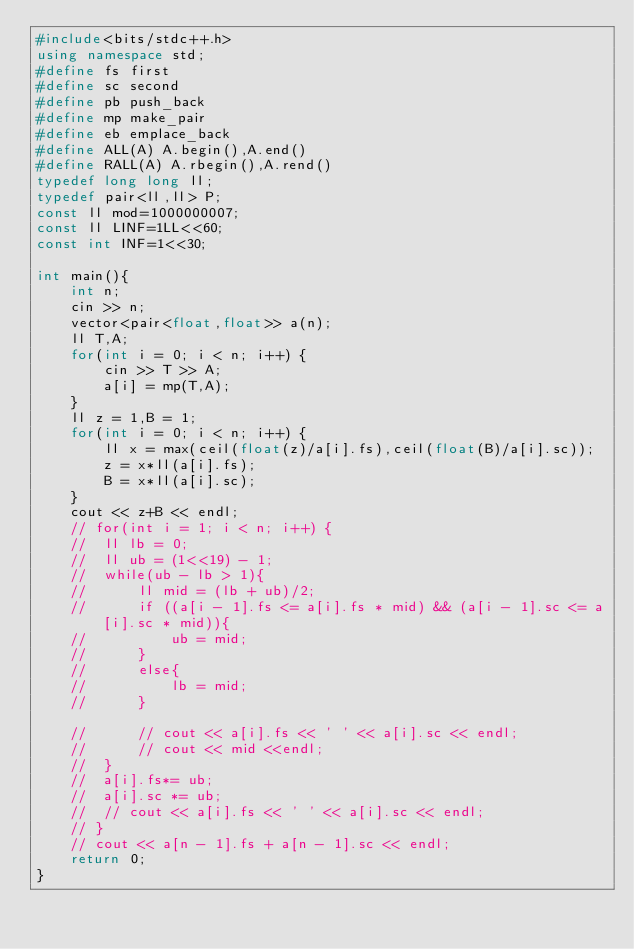<code> <loc_0><loc_0><loc_500><loc_500><_C++_>#include<bits/stdc++.h>
using namespace std;
#define fs first
#define sc second
#define pb push_back
#define mp make_pair
#define eb emplace_back
#define ALL(A) A.begin(),A.end()
#define RALL(A) A.rbegin(),A.rend()
typedef long long ll;
typedef pair<ll,ll> P;
const ll mod=1000000007;
const ll LINF=1LL<<60;
const int INF=1<<30;

int main(){
	int n;
	cin >> n;
	vector<pair<float,float>> a(n);
	ll T,A;
	for(int i = 0; i < n; i++) {
		cin >> T >> A;
		a[i] = mp(T,A); 
	}
	ll z = 1,B = 1;
	for(int i = 0; i < n; i++) {
		ll x = max(ceil(float(z)/a[i].fs),ceil(float(B)/a[i].sc));
		z = x*ll(a[i].fs);
		B = x*ll(a[i].sc);
	}
	cout << z+B << endl;
	// for(int i = 1; i < n; i++) {
	// 	ll lb = 0;
	// 	ll ub = (1<<19) - 1;
	// 	while(ub - lb > 1){
	// 		ll mid = (lb + ub)/2;
	// 		if ((a[i - 1].fs <= a[i].fs * mid) && (a[i - 1].sc <= a[i].sc * mid)){
	// 			ub = mid;
	// 		}
	// 		else{
	// 			lb = mid;
	// 		}

	// 		// cout << a[i].fs << ' ' << a[i].sc << endl;
	// 		// cout << mid <<endl;
	// 	} 
	// 	a[i].fs*= ub;
	// 	a[i].sc *= ub;
	// 	// cout << a[i].fs << ' ' << a[i].sc << endl;
	// }
	// cout << a[n - 1].fs + a[n - 1].sc << endl;
	return 0;
}</code> 